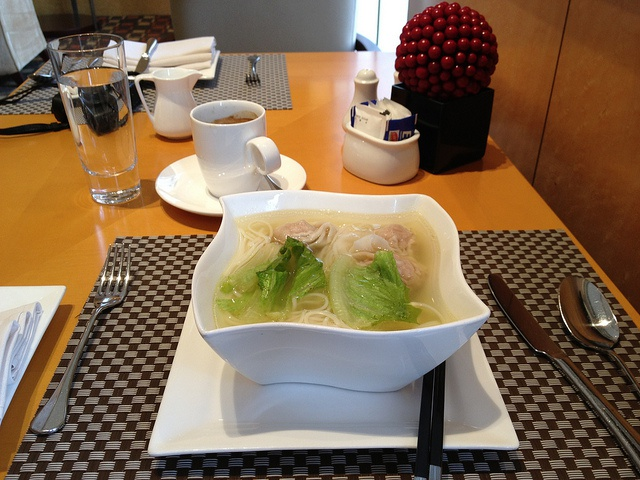Describe the objects in this image and their specific colors. I can see dining table in darkgray, black, orange, gray, and maroon tones, bowl in darkgray, gray, tan, and lightgray tones, cup in darkgray, orange, black, and gray tones, chair in darkgray, gray, and black tones, and cup in darkgray and lightgray tones in this image. 